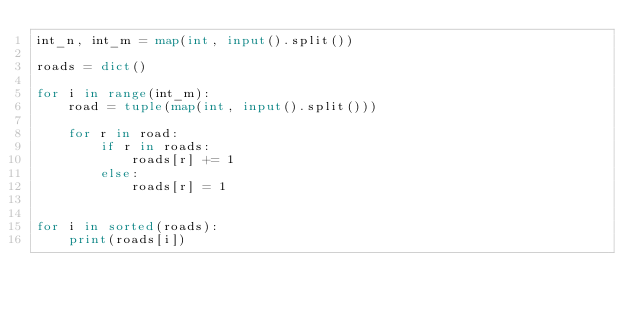<code> <loc_0><loc_0><loc_500><loc_500><_Python_>int_n, int_m = map(int, input().split())

roads = dict()

for i in range(int_m):
    road = tuple(map(int, input().split()))

    for r in road:
        if r in roads:
            roads[r] += 1
        else:
            roads[r] = 1


for i in sorted(roads):
    print(roads[i])




</code> 